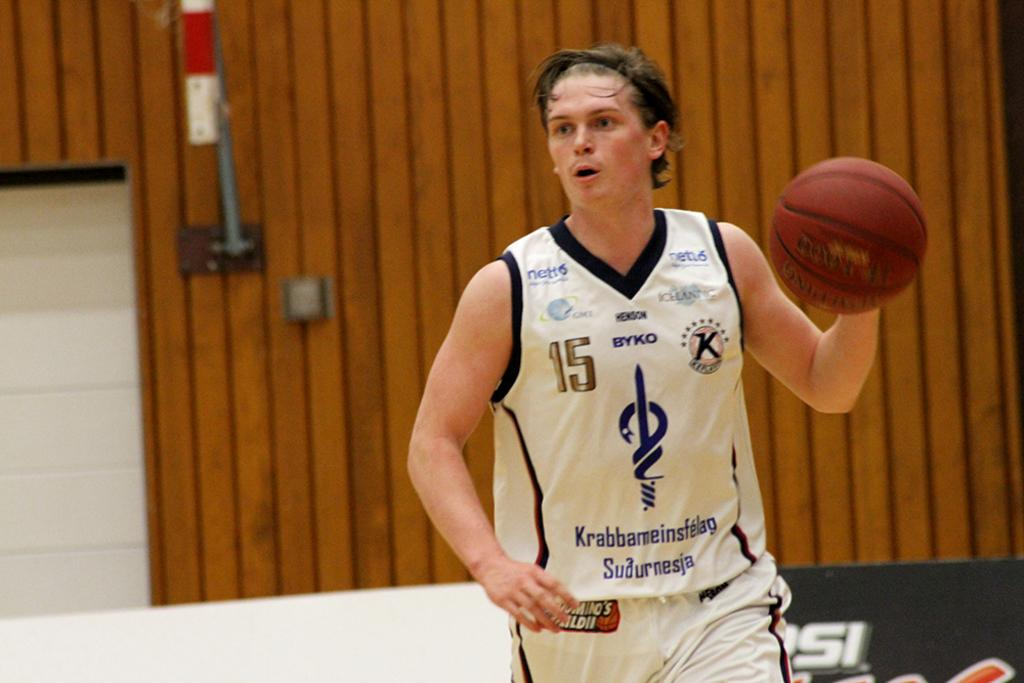<image>
Give a short and clear explanation of the subsequent image. A man holds a basketball up wearing a jersey that says Byko on it. 